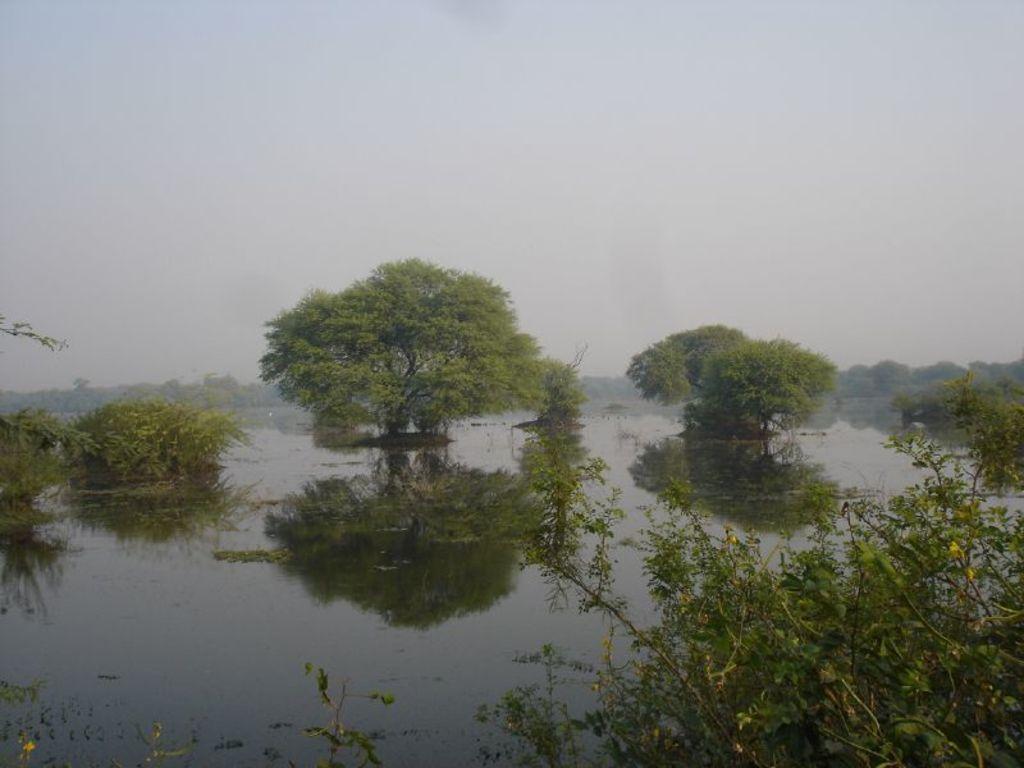In one or two sentences, can you explain what this image depicts? In this image we can see many trees and plants. We can see the reflection of trees on the water surface. There is a lake in the image. We can see the sky in the image. 